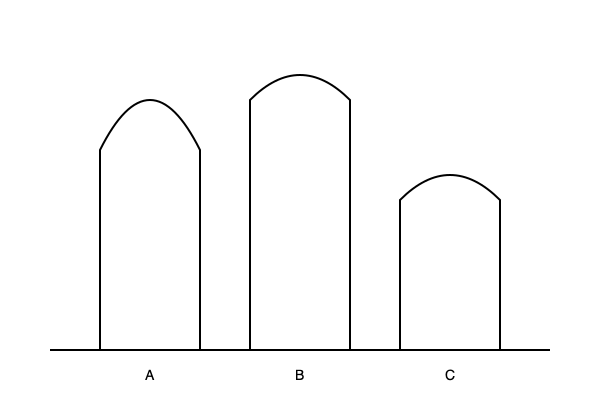Analyze the silhouettes of the three garment styles shown above. Which style would be most suitable for creating a dramatic, voluminous evening gown? To determine the most suitable silhouette for a dramatic, voluminous evening gown, let's analyze each style:

1. Style A:
   - Has a wider base and narrower top
   - Creates a bell-like shape
   - Offers moderate volume at the bottom

2. Style B:
   - Has the widest silhouette overall
   - Provides significant volume from the shoulders to the hem
   - Creates a dramatic A-line or ball gown shape

3. Style C:
   - Has a narrower silhouette compared to A and B
   - Offers some volume at the bottom, but less than A and B
   - Creates a more fitted look overall

For a dramatic, voluminous evening gown, we want maximum impact and fullness. Style B provides the most volume and the widest silhouette, making it ideal for creating a statement piece. The full shape from shoulders to hem allows for ample fabric use and creates a grand, sweeping effect that's perfect for formal occasions.

Style A could also work for a voluminous gown, but it doesn't offer as much drama as Style B. Style C, while elegant, doesn't provide enough volume for the desired effect.
Answer: Style B 